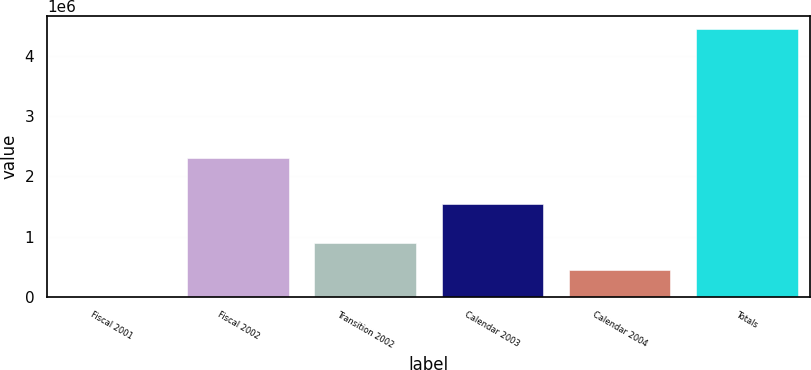Convert chart to OTSL. <chart><loc_0><loc_0><loc_500><loc_500><bar_chart><fcel>Fiscal 2001<fcel>Fiscal 2002<fcel>Transition 2002<fcel>Calendar 2003<fcel>Calendar 2004<fcel>Totals<nl><fcel>7960<fcel>2.3117e+06<fcel>893837<fcel>1.54948e+06<fcel>450898<fcel>4.43734e+06<nl></chart> 